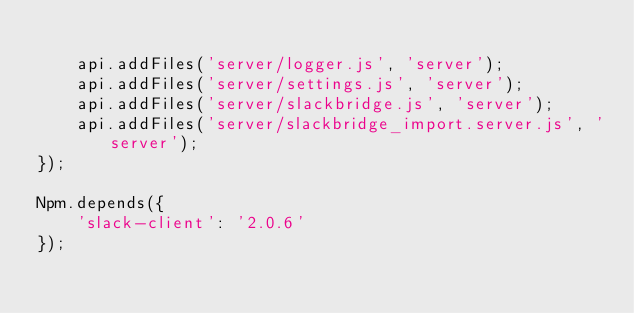Convert code to text. <code><loc_0><loc_0><loc_500><loc_500><_JavaScript_>
	api.addFiles('server/logger.js', 'server');
	api.addFiles('server/settings.js', 'server');
	api.addFiles('server/slackbridge.js', 'server');
	api.addFiles('server/slackbridge_import.server.js', 'server');
});

Npm.depends({
	'slack-client': '2.0.6'
});
</code> 